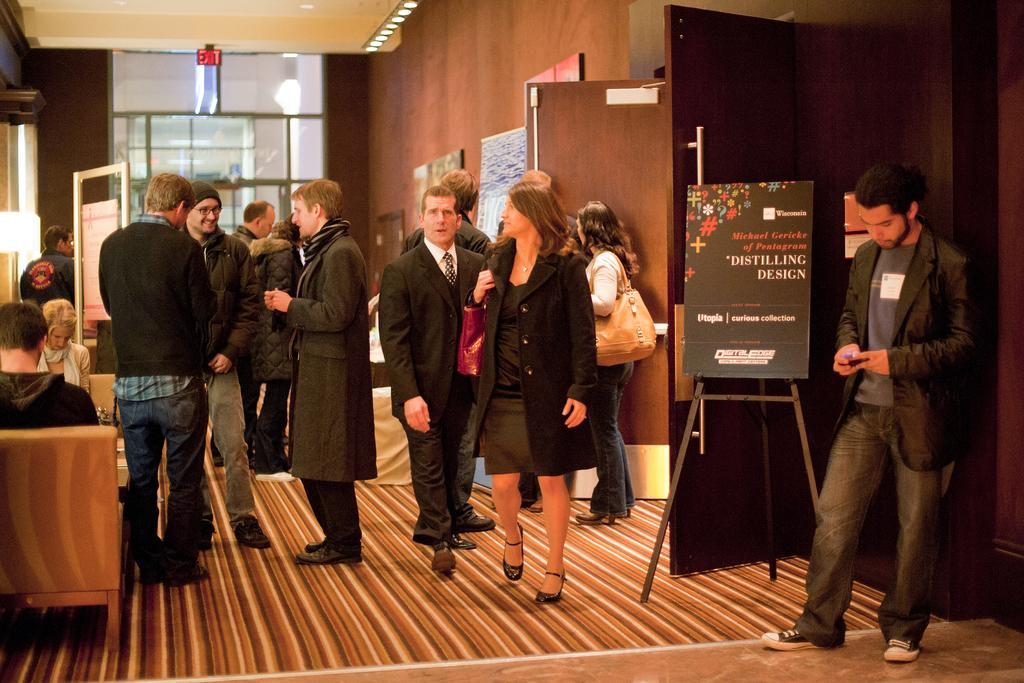What are the people in the image doing? There are people standing and sitting on a couch in the image. Where is the image taken? The image is taken in a room. What type of grass can be seen growing on the property in the image? There is no grass or property visible in the image; it is taken in a room with people standing and sitting on a couch. 